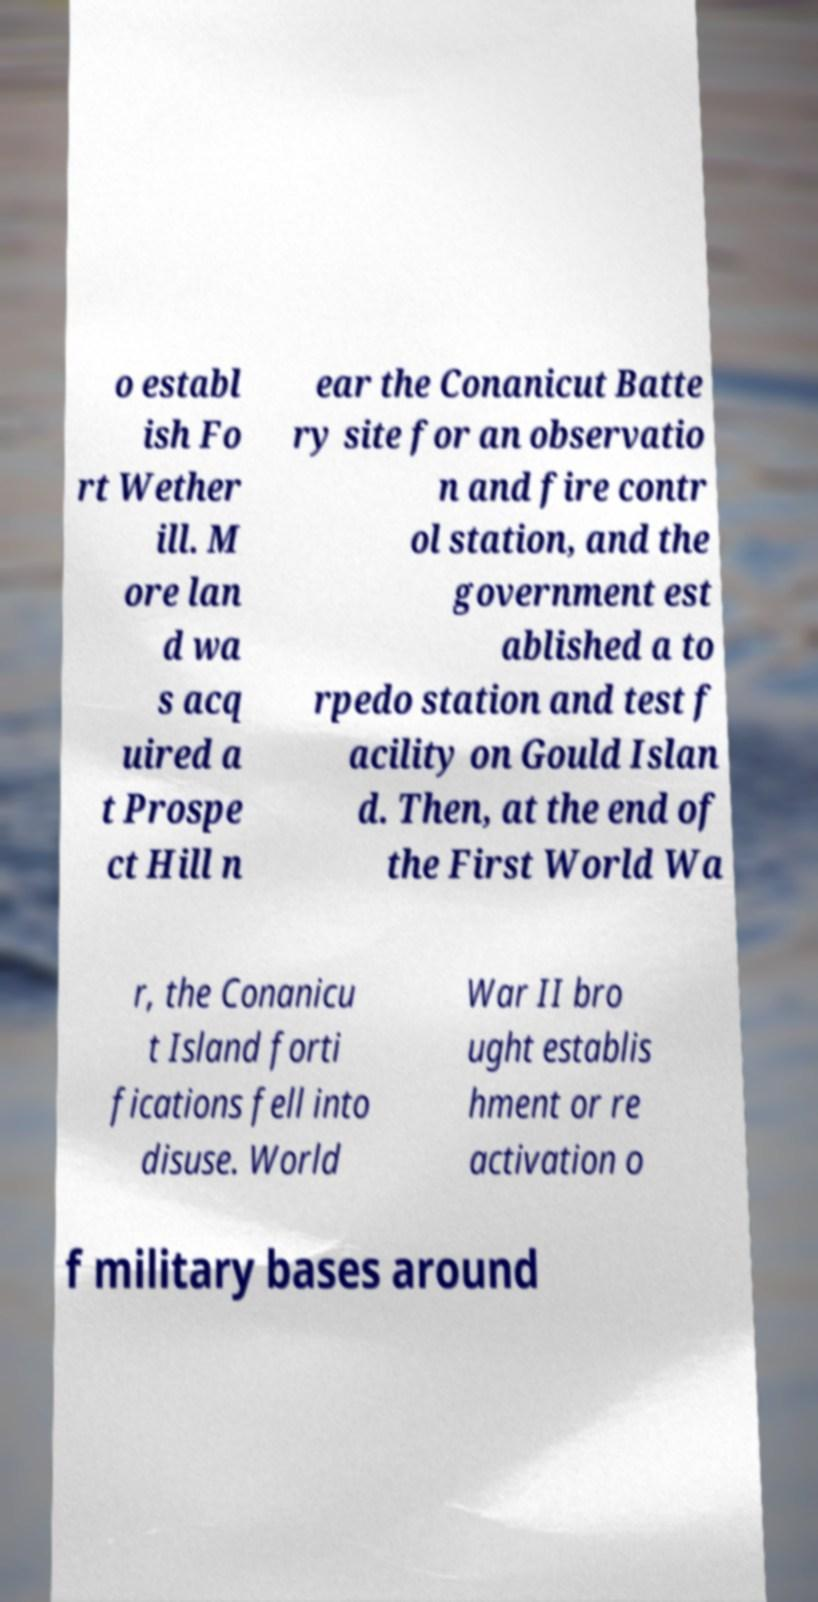What messages or text are displayed in this image? I need them in a readable, typed format. o establ ish Fo rt Wether ill. M ore lan d wa s acq uired a t Prospe ct Hill n ear the Conanicut Batte ry site for an observatio n and fire contr ol station, and the government est ablished a to rpedo station and test f acility on Gould Islan d. Then, at the end of the First World Wa r, the Conanicu t Island forti fications fell into disuse. World War II bro ught establis hment or re activation o f military bases around 